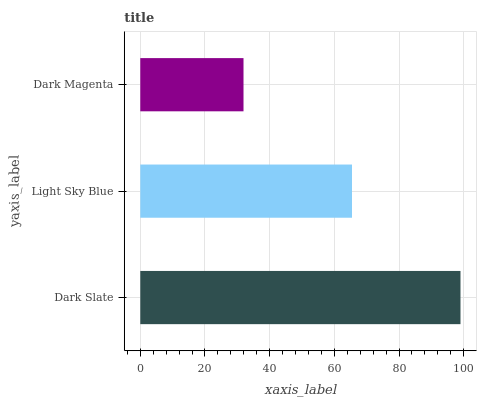Is Dark Magenta the minimum?
Answer yes or no. Yes. Is Dark Slate the maximum?
Answer yes or no. Yes. Is Light Sky Blue the minimum?
Answer yes or no. No. Is Light Sky Blue the maximum?
Answer yes or no. No. Is Dark Slate greater than Light Sky Blue?
Answer yes or no. Yes. Is Light Sky Blue less than Dark Slate?
Answer yes or no. Yes. Is Light Sky Blue greater than Dark Slate?
Answer yes or no. No. Is Dark Slate less than Light Sky Blue?
Answer yes or no. No. Is Light Sky Blue the high median?
Answer yes or no. Yes. Is Light Sky Blue the low median?
Answer yes or no. Yes. Is Dark Slate the high median?
Answer yes or no. No. Is Dark Magenta the low median?
Answer yes or no. No. 